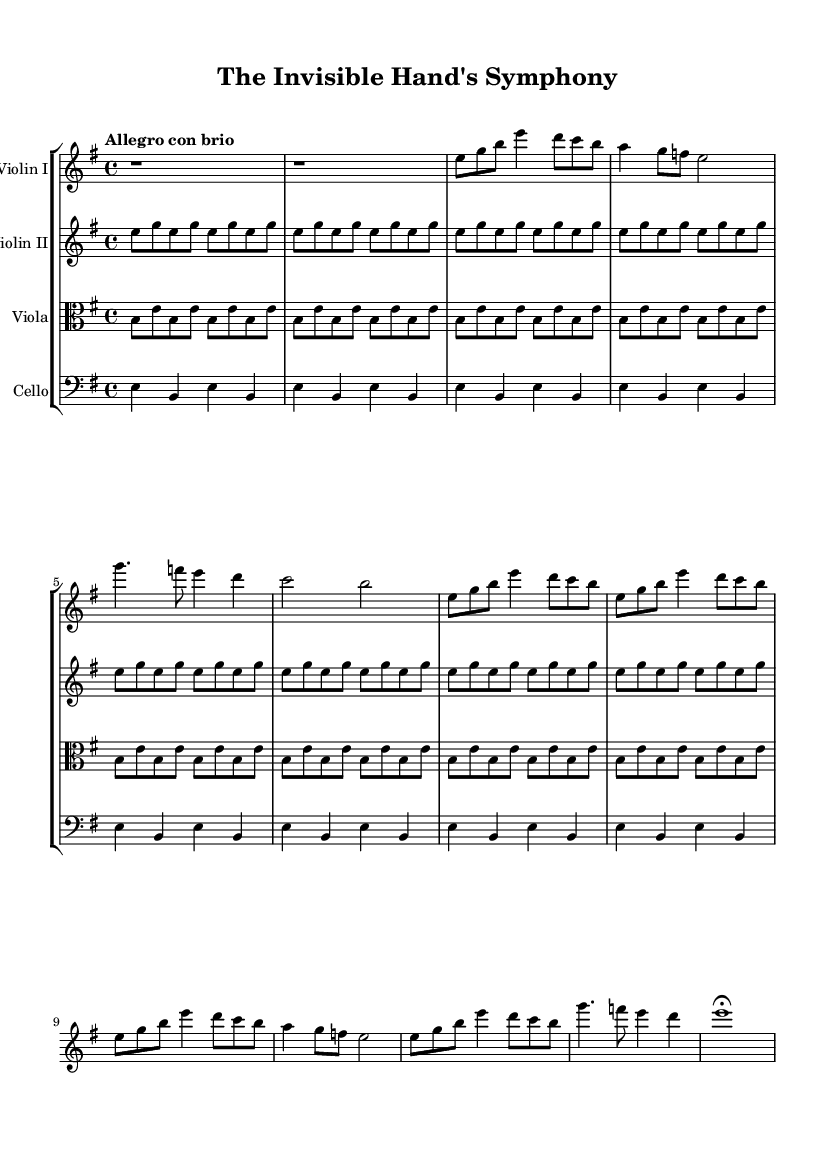What is the key signature of this music? The key signature is indicated by the sharp or flat symbols at the beginning of the staff. In this case, there are no sharps or flats shown, which indicates that the key is E minor, as it follows the pattern of E minor with one sharp (F#).
Answer: E minor What is the time signature of this music? The time signature appears at the beginning of the staff as two numbers stacked vertically. Here, it is written as 4 over 4, which tells us there are four beats in a measure and the quarter note gets one beat.
Answer: 4/4 What is the tempo marking for this piece? The tempo marking is indicated below the staff and gives the performer an idea of the speed at which to play. It states "Allegro con brio," suggesting a lively, brisk pace.
Answer: Allegro con brio Which theme represents individual interests in the music? The theme that symbolizes the individual interests can be determined by analyzing the labels or musical phrases. In this piece, Theme A is referred to as the Individual, as represented by the music notes first mentioned.
Answer: Theme A How many measures are in the development section? To ascertain the number of measures, one must count the musical bars defined by vertical lines separating the sections. The Development section is shown to repeat two measures, and the repeated material is brief. Thus, it counts as two measures.
Answer: 2 Which instrument plays the main theme in the recapitulation section? The main theme in the recapitulation can be identified by looking at the highest notes or notable lines presented. Here, Violin I is playing the significant melody, which is characteristic of the Romantic era.
Answer: Violin I What does the term "fermata" indicate at the end of the piece? A fermata is a symbol placed over a note or rest to indicate that it should be held longer than its usual duration. The presence of one at the end suggests that E should be sustained as a strong conclusion, often used for effect in Romantic compositions.
Answer: Fermata 